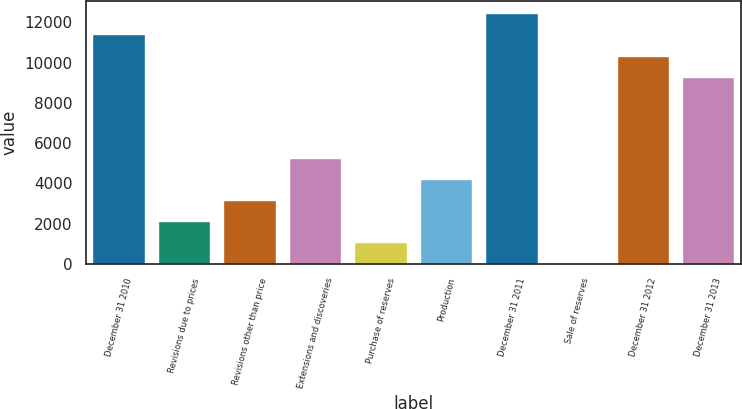Convert chart to OTSL. <chart><loc_0><loc_0><loc_500><loc_500><bar_chart><fcel>December 31 2010<fcel>Revisions due to prices<fcel>Revisions other than price<fcel>Extensions and discoveries<fcel>Purchase of reserves<fcel>Production<fcel>December 31 2011<fcel>Sale of reserves<fcel>December 31 2012<fcel>December 31 2013<nl><fcel>11402.8<fcel>2106.8<fcel>3154.2<fcel>5249<fcel>1059.4<fcel>4201.6<fcel>12450.2<fcel>12<fcel>10355.4<fcel>9308<nl></chart> 